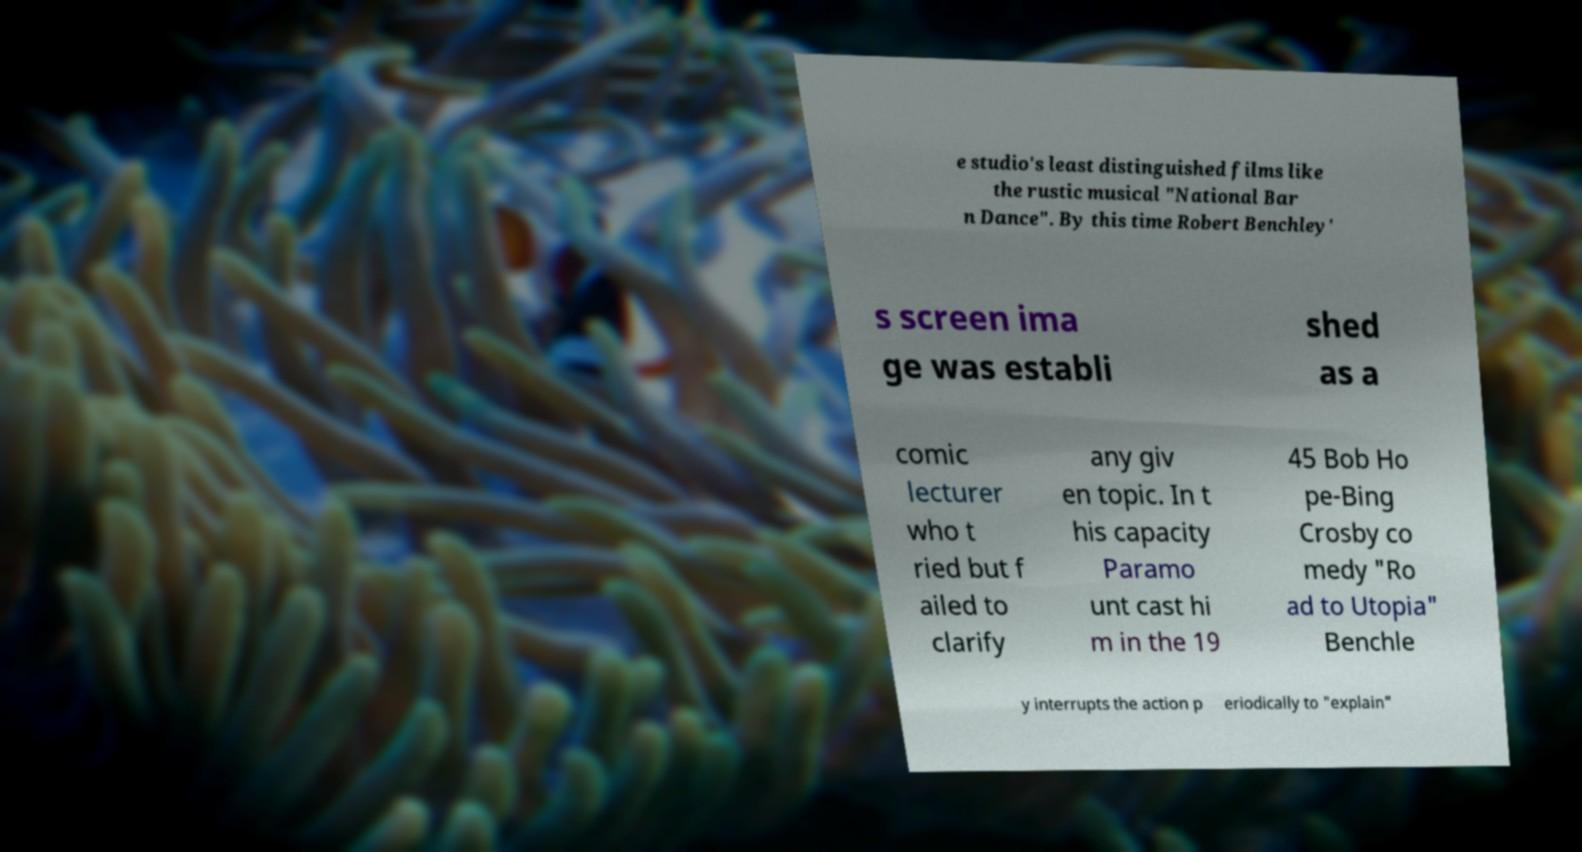For documentation purposes, I need the text within this image transcribed. Could you provide that? e studio's least distinguished films like the rustic musical "National Bar n Dance". By this time Robert Benchley' s screen ima ge was establi shed as a comic lecturer who t ried but f ailed to clarify any giv en topic. In t his capacity Paramo unt cast hi m in the 19 45 Bob Ho pe-Bing Crosby co medy "Ro ad to Utopia" Benchle y interrupts the action p eriodically to "explain" 